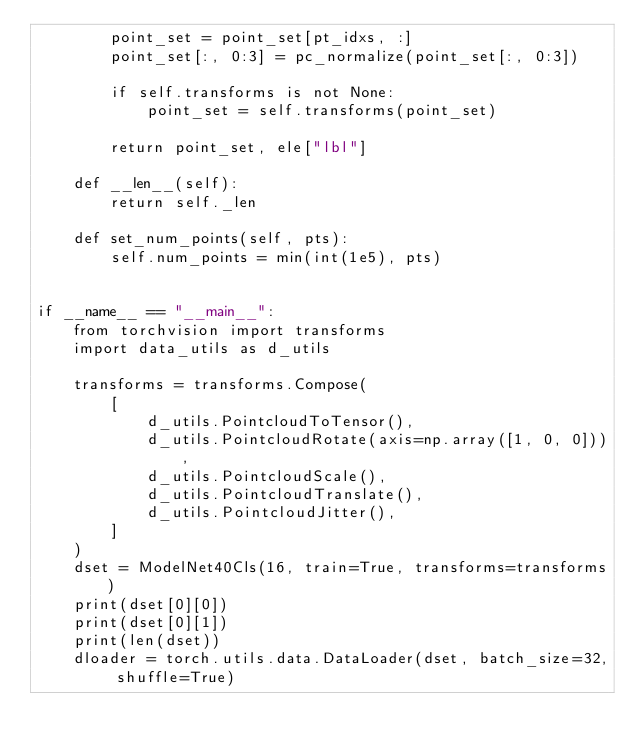<code> <loc_0><loc_0><loc_500><loc_500><_Python_>        point_set = point_set[pt_idxs, :]
        point_set[:, 0:3] = pc_normalize(point_set[:, 0:3])

        if self.transforms is not None:
            point_set = self.transforms(point_set)

        return point_set, ele["lbl"]

    def __len__(self):
        return self._len

    def set_num_points(self, pts):
        self.num_points = min(int(1e5), pts)


if __name__ == "__main__":
    from torchvision import transforms
    import data_utils as d_utils

    transforms = transforms.Compose(
        [
            d_utils.PointcloudToTensor(),
            d_utils.PointcloudRotate(axis=np.array([1, 0, 0])),
            d_utils.PointcloudScale(),
            d_utils.PointcloudTranslate(),
            d_utils.PointcloudJitter(),
        ]
    )
    dset = ModelNet40Cls(16, train=True, transforms=transforms)
    print(dset[0][0])
    print(dset[0][1])
    print(len(dset))
    dloader = torch.utils.data.DataLoader(dset, batch_size=32, shuffle=True)
</code> 